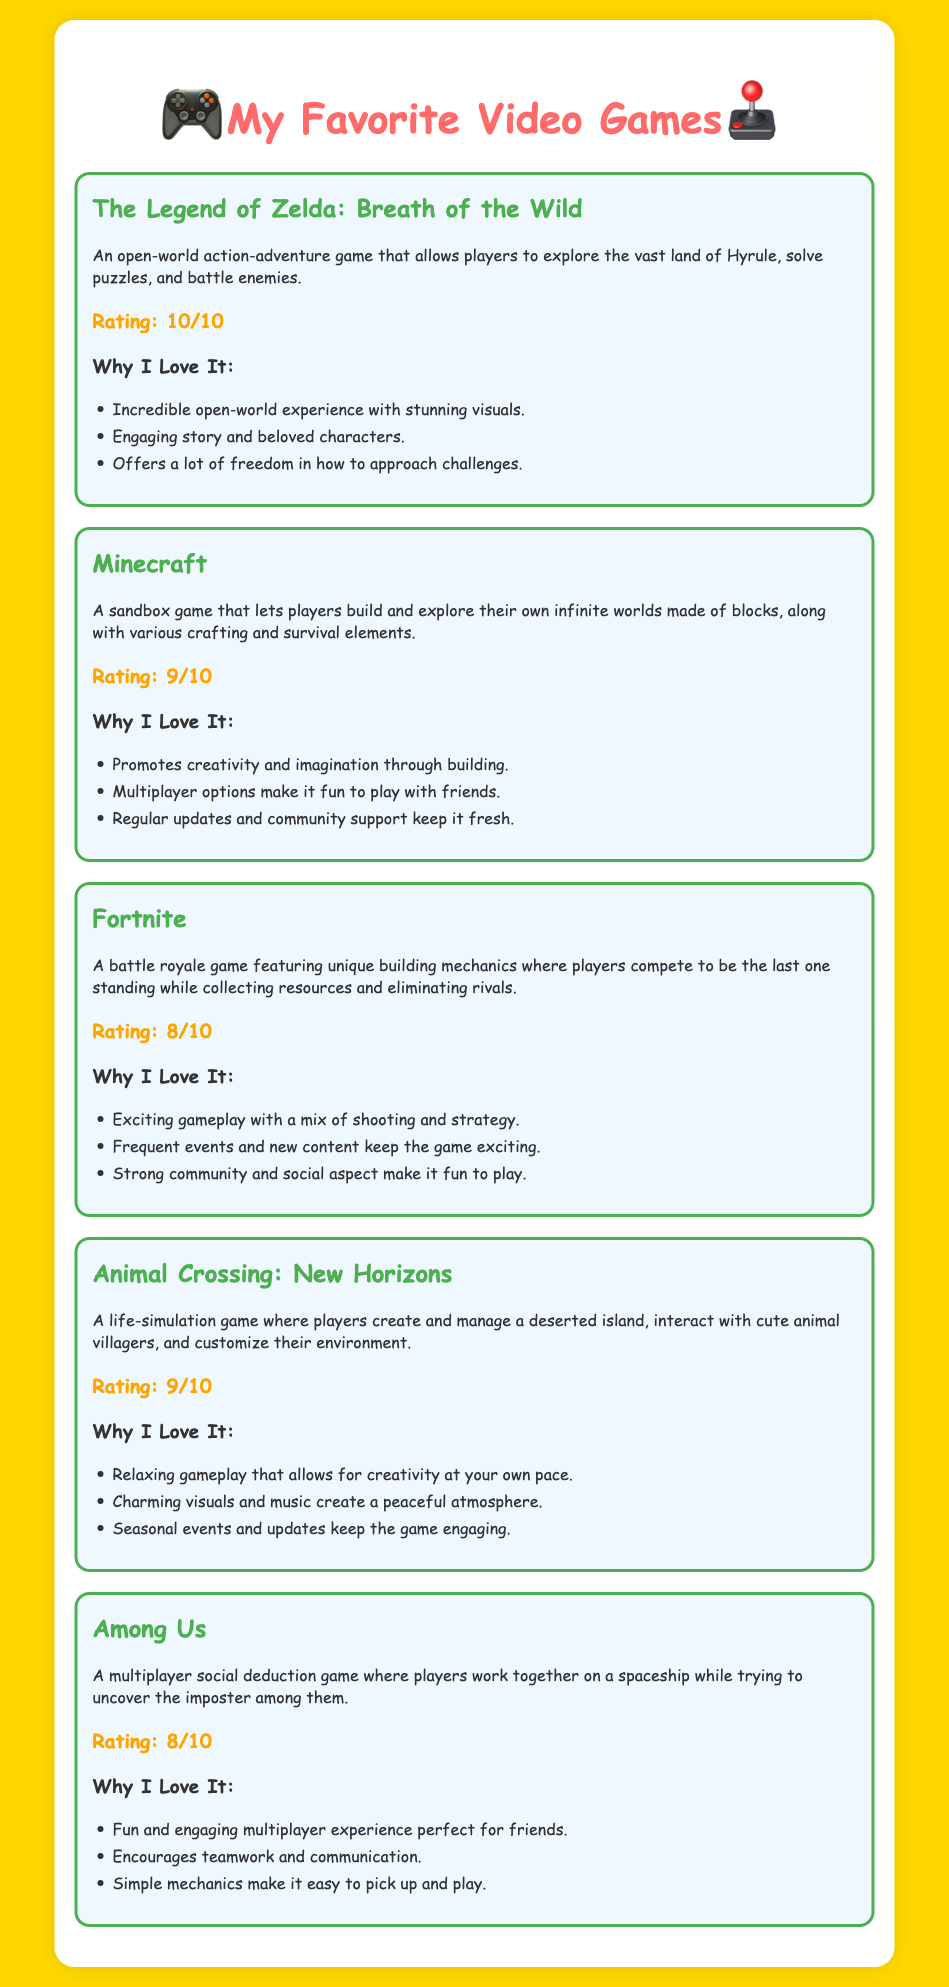What is the highest rating among the games? The highest rating given in the document is 10 out of 10 for "The Legend of Zelda: Breath of the Wild."
Answer: 10/10 What game features building mechanics? The game that features unique building mechanics is "Fortnite."
Answer: Fortnite Which game has a relaxing gameplay style? "Animal Crossing: New Horizons" is noted for its relaxing gameplay that allows creativity at your own pace.
Answer: Animal Crossing: New Horizons How many games have a rating of 8 out of 10? There are two games in the document with a rating of 8 out of 10: "Fortnite" and "Among Us."
Answer: 2 What is a common theme among the reasons for loving the games? Many games are praised for promoting creativity, community, and engaging gameplay, suggesting a preference for interactive and social experiences.
Answer: Creativity and community Which game is described as a life-simulation game? The game that is described as a life-simulation game is "Animal Crossing: New Horizons."
Answer: Animal Crossing: New Horizons 